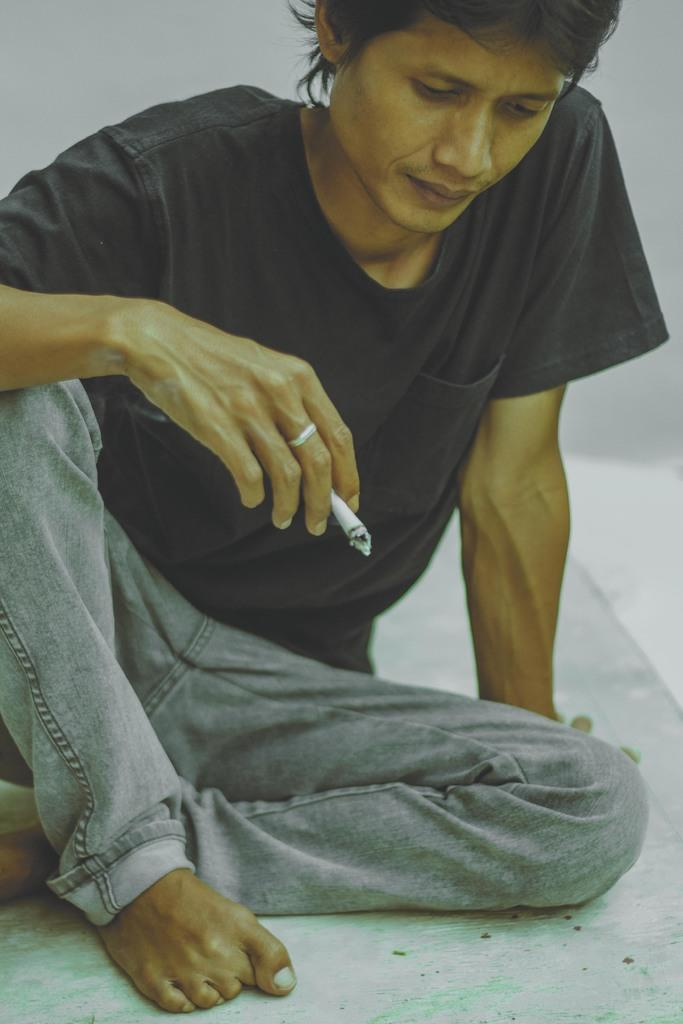What is the main subject of the image? There is a man in the image. What is the man doing in the image? The man is sitting on the floor. What is the man holding in the image? The man is holding a cigarette with his two fingers. What type of stamp can be seen on the man's forehead in the image? There is no stamp present on the man's forehead in the image. What trail does the man leave behind as he walks in the image? The man is sitting on the floor and not walking, so there is no trail left behind. 